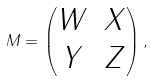<formula> <loc_0><loc_0><loc_500><loc_500>M = \begin{pmatrix} W & X \\ Y & Z \end{pmatrix} ,</formula> 